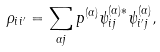Convert formula to latex. <formula><loc_0><loc_0><loc_500><loc_500>\rho _ { i i ^ { \prime } } = \sum _ { \alpha j } p ^ { ( \alpha ) } \psi _ { i j } ^ { ( \alpha ) \ast } \psi _ { i ^ { \prime } j } ^ { ( \alpha ) } ,</formula> 